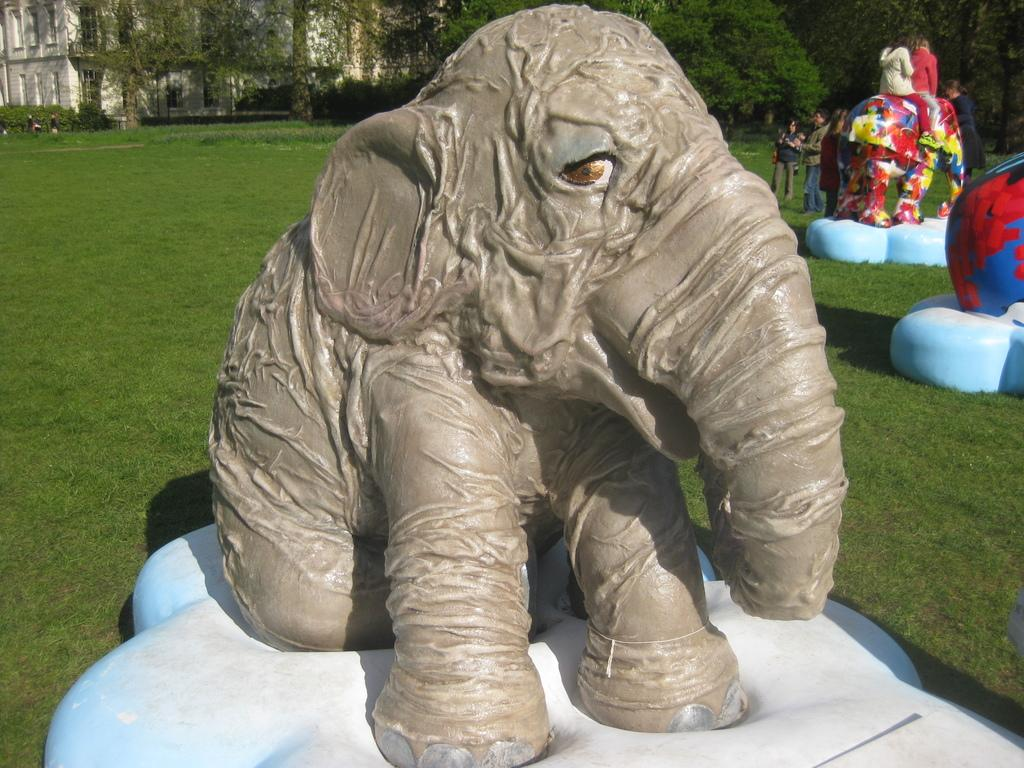What type of statues are present in the image? There are elephant statues in the image. What are people doing with the elephant statues? People are sitting on the elephant statues. What can be seen in the background of the image? There are trees and buildings in the background of the image. What type of toothbrush is the elephant statue using in the image? There is no toothbrush present in the image, and the elephant statues are not using any toothbrushes. 